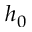<formula> <loc_0><loc_0><loc_500><loc_500>h _ { 0 }</formula> 